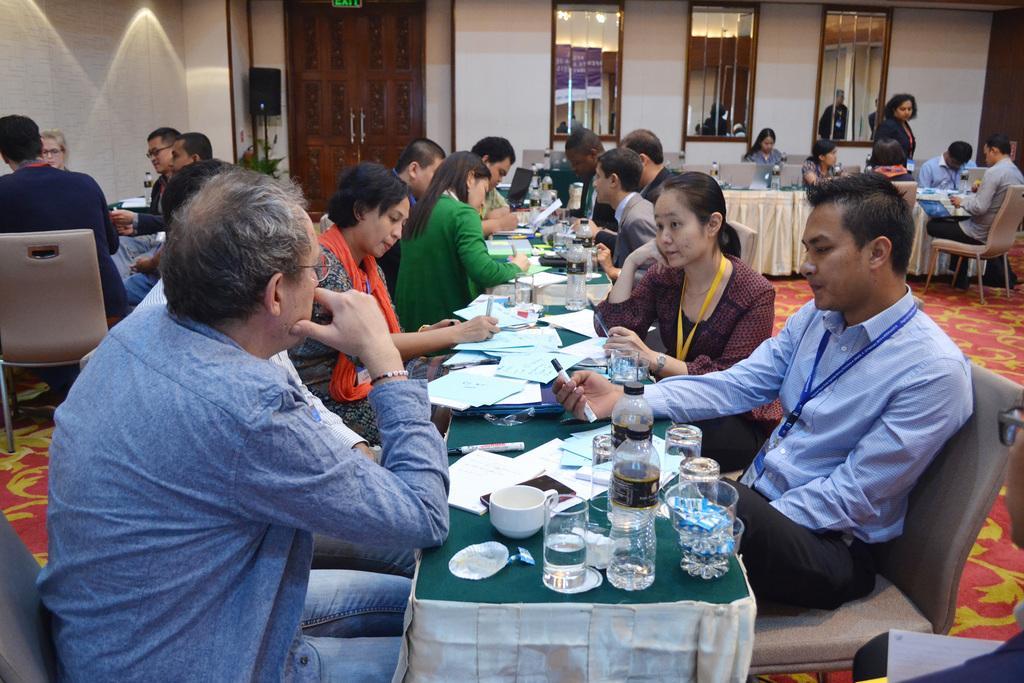Can you describe this image briefly? In this picture there is a group of men and women sitting on the table and discussing something. On the front side of the table there are some glasses, water bottle and papers. Behind there is a group of girl sitting and discussing something. In the background there are three mirrors on the white wall and inside there is a wooden door. 